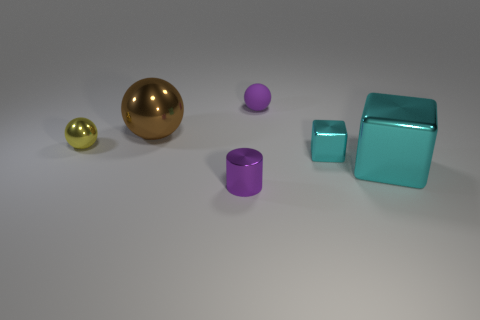Subtract all tiny yellow metal balls. How many balls are left? 2 Add 1 large blue blocks. How many objects exist? 7 Subtract all yellow spheres. How many spheres are left? 2 Subtract 1 cubes. How many cubes are left? 1 Subtract 0 cyan balls. How many objects are left? 6 Subtract all cylinders. How many objects are left? 5 Subtract all red balls. Subtract all green blocks. How many balls are left? 3 Subtract all purple cylinders. How many green balls are left? 0 Subtract all brown metallic balls. Subtract all tiny balls. How many objects are left? 3 Add 4 small purple metal cylinders. How many small purple metal cylinders are left? 5 